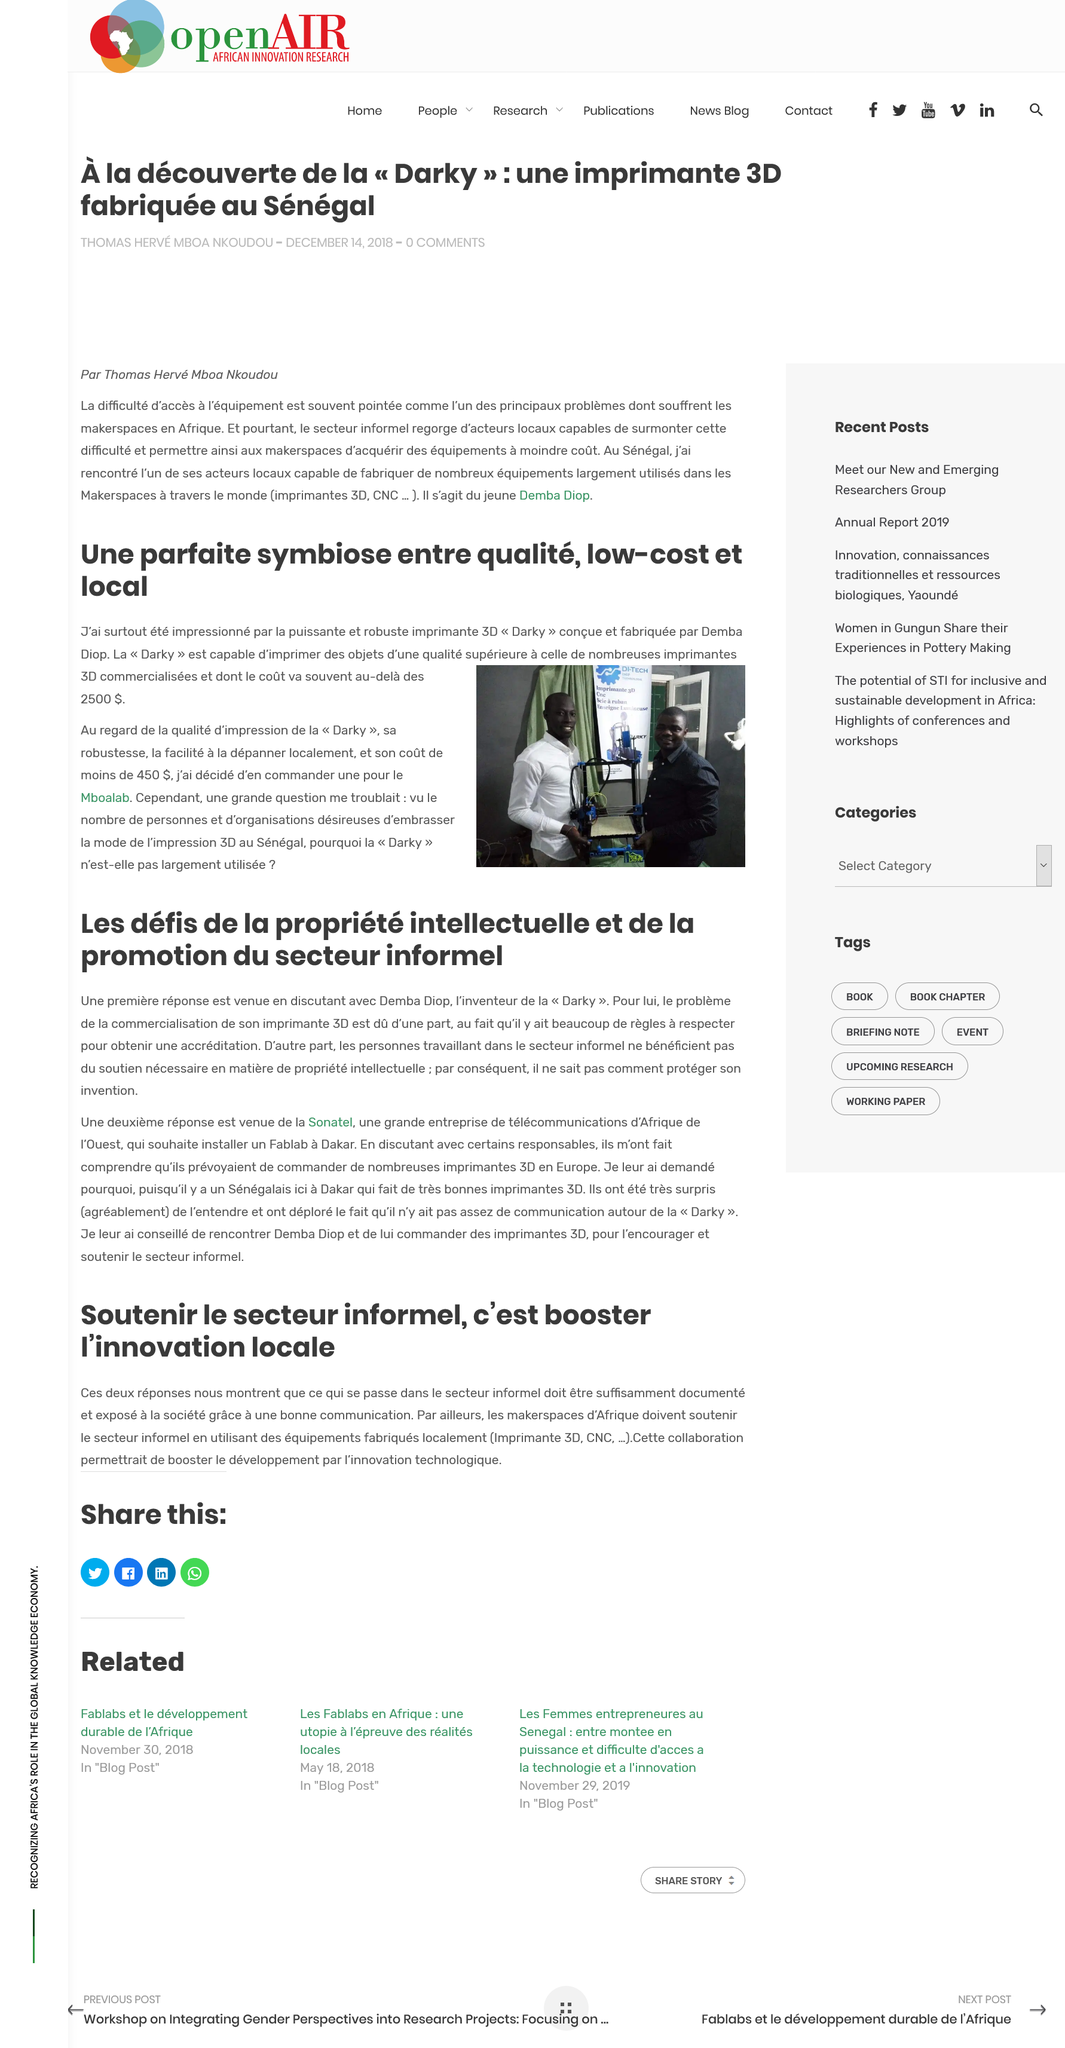Identify some key points in this picture. The cost of an impression using the Darky 3D printer is less than 450 USD. Darky costs 2500 dollars. Demba Diop is the inventor of "Darky," a revolutionary new technology that has captured the attention of people all over the world. Another challenge in the commercialization of 3D printing is that individuals working in the informal sector are unable to benefit from the protection of intellectual property. Darky is capable of printing objects of superior quality from commercial 3D printers at a lower price than what is typical of such printers. 